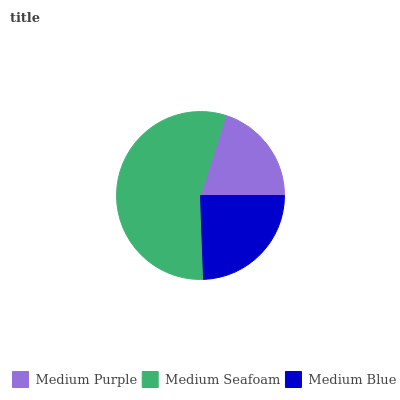Is Medium Purple the minimum?
Answer yes or no. Yes. Is Medium Seafoam the maximum?
Answer yes or no. Yes. Is Medium Blue the minimum?
Answer yes or no. No. Is Medium Blue the maximum?
Answer yes or no. No. Is Medium Seafoam greater than Medium Blue?
Answer yes or no. Yes. Is Medium Blue less than Medium Seafoam?
Answer yes or no. Yes. Is Medium Blue greater than Medium Seafoam?
Answer yes or no. No. Is Medium Seafoam less than Medium Blue?
Answer yes or no. No. Is Medium Blue the high median?
Answer yes or no. Yes. Is Medium Blue the low median?
Answer yes or no. Yes. Is Medium Seafoam the high median?
Answer yes or no. No. Is Medium Purple the low median?
Answer yes or no. No. 